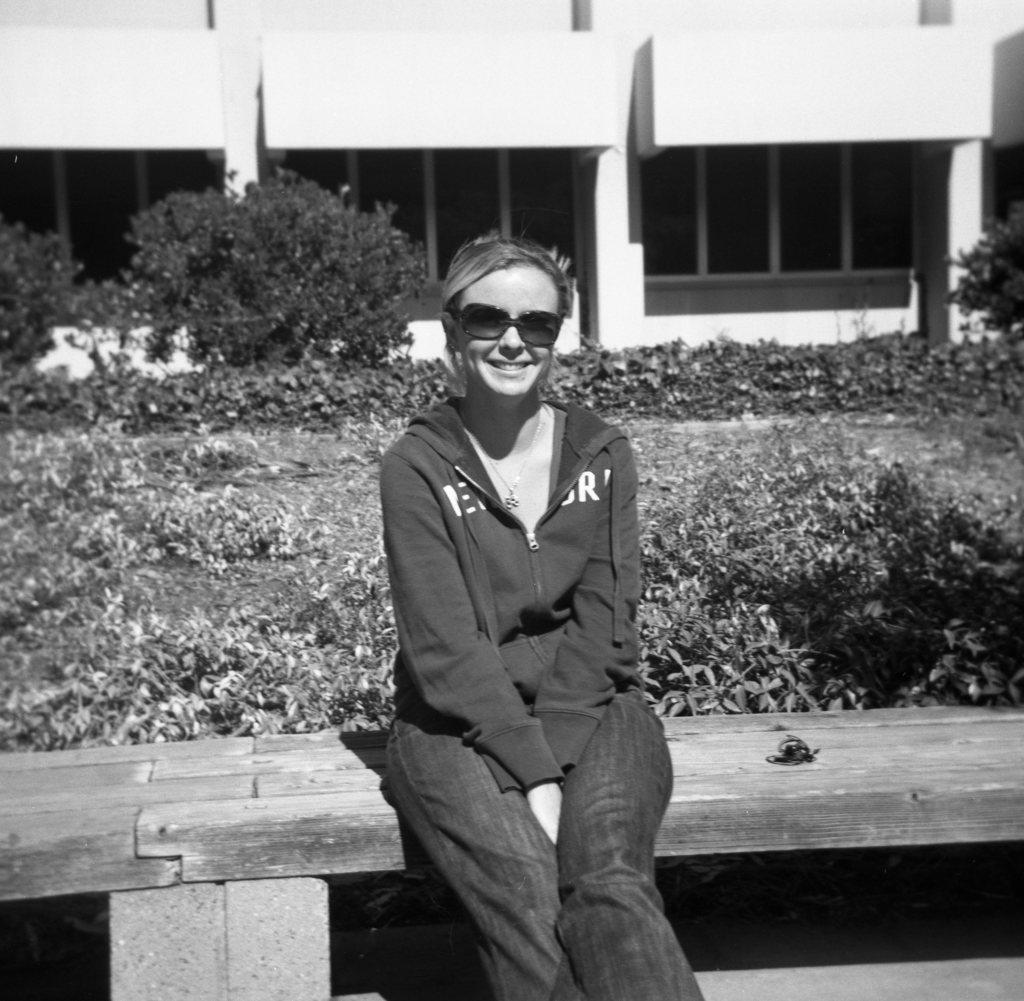Can you describe this image briefly? I see this is a black and white image and I see a woman who is sitting on this bench and I see that she is smiling. In the background I see the planets and I see the building. 